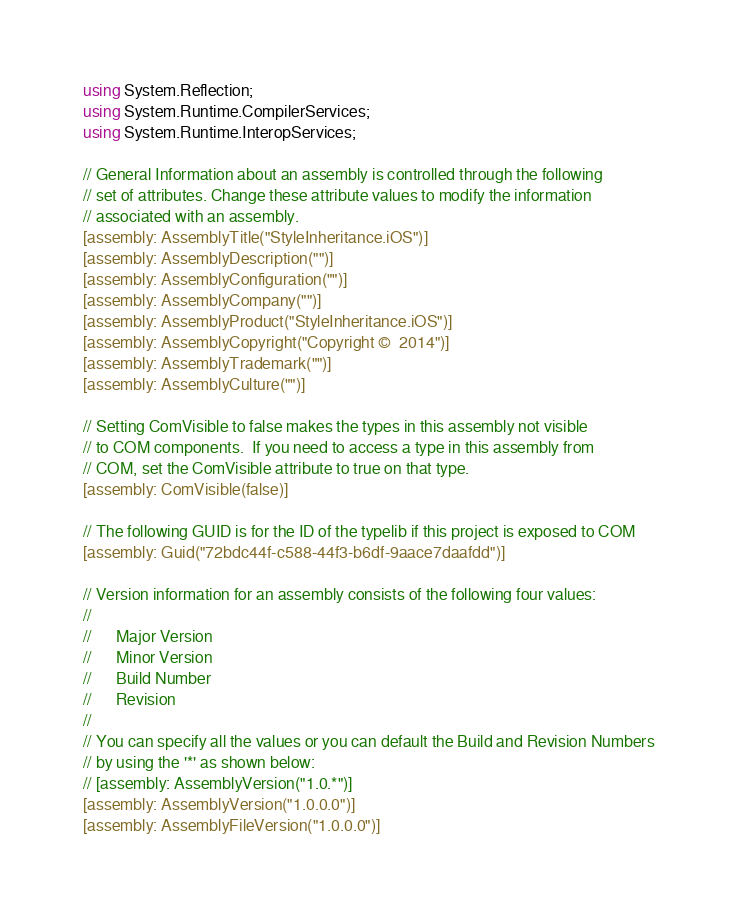<code> <loc_0><loc_0><loc_500><loc_500><_C#_>using System.Reflection;
using System.Runtime.CompilerServices;
using System.Runtime.InteropServices;

// General Information about an assembly is controlled through the following 
// set of attributes. Change these attribute values to modify the information
// associated with an assembly.
[assembly: AssemblyTitle("StyleInheritance.iOS")]
[assembly: AssemblyDescription("")]
[assembly: AssemblyConfiguration("")]
[assembly: AssemblyCompany("")]
[assembly: AssemblyProduct("StyleInheritance.iOS")]
[assembly: AssemblyCopyright("Copyright ©  2014")]
[assembly: AssemblyTrademark("")]
[assembly: AssemblyCulture("")]

// Setting ComVisible to false makes the types in this assembly not visible 
// to COM components.  If you need to access a type in this assembly from 
// COM, set the ComVisible attribute to true on that type.
[assembly: ComVisible(false)]

// The following GUID is for the ID of the typelib if this project is exposed to COM
[assembly: Guid("72bdc44f-c588-44f3-b6df-9aace7daafdd")]

// Version information for an assembly consists of the following four values:
//
//      Major Version
//      Minor Version 
//      Build Number
//      Revision
//
// You can specify all the values or you can default the Build and Revision Numbers 
// by using the '*' as shown below:
// [assembly: AssemblyVersion("1.0.*")]
[assembly: AssemblyVersion("1.0.0.0")]
[assembly: AssemblyFileVersion("1.0.0.0")]
</code> 